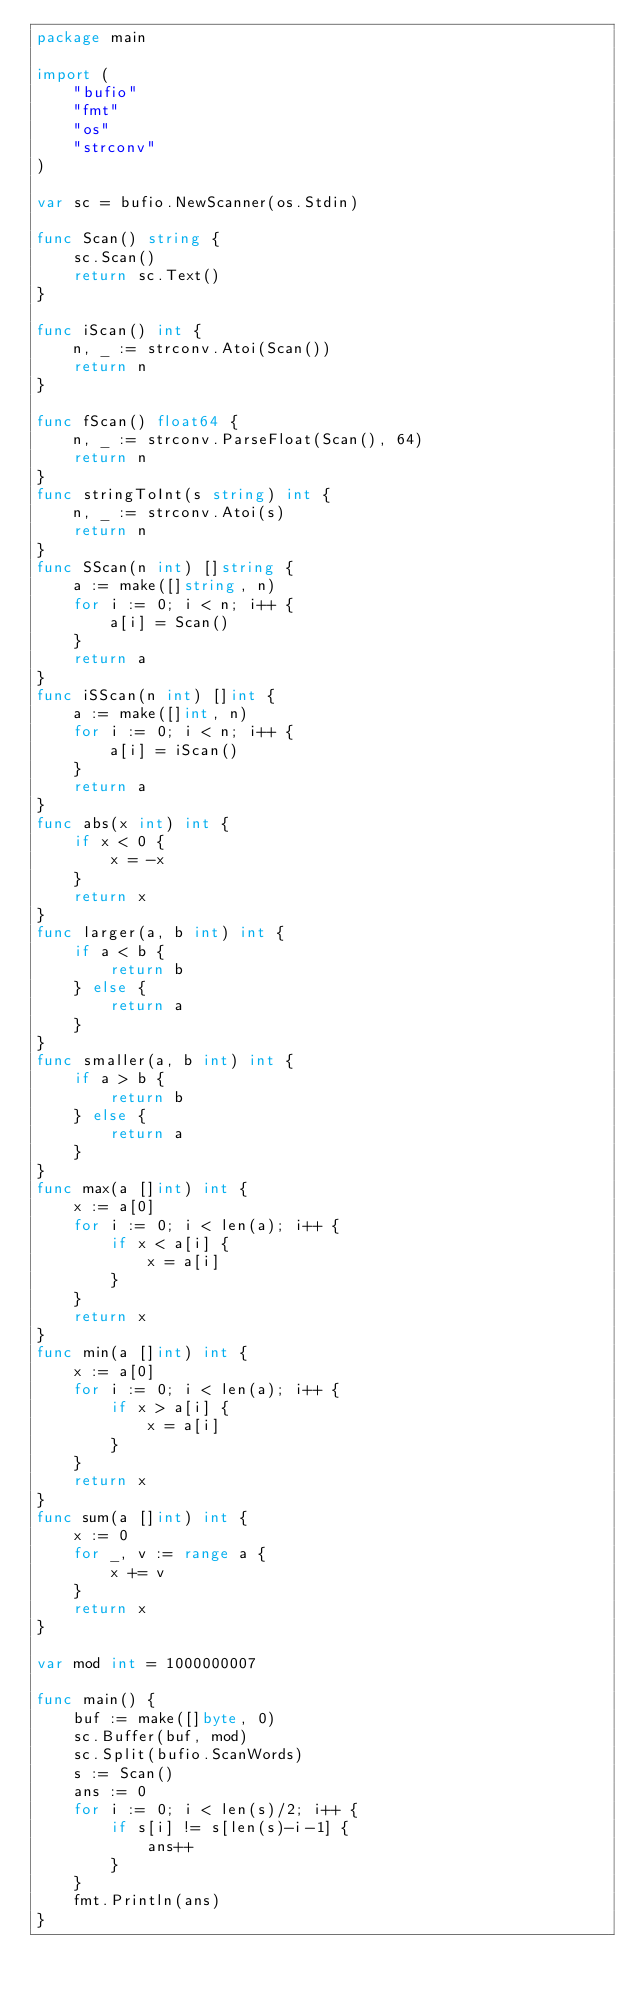Convert code to text. <code><loc_0><loc_0><loc_500><loc_500><_Go_>package main

import (
	"bufio"
	"fmt"
	"os"
	"strconv"
)

var sc = bufio.NewScanner(os.Stdin)

func Scan() string {
	sc.Scan()
	return sc.Text()
}

func iScan() int {
	n, _ := strconv.Atoi(Scan())
	return n
}

func fScan() float64 {
	n, _ := strconv.ParseFloat(Scan(), 64)
	return n
}
func stringToInt(s string) int {
	n, _ := strconv.Atoi(s)
	return n
}
func SScan(n int) []string {
	a := make([]string, n)
	for i := 0; i < n; i++ {
		a[i] = Scan()
	}
	return a
}
func iSScan(n int) []int {
	a := make([]int, n)
	for i := 0; i < n; i++ {
		a[i] = iScan()
	}
	return a
}
func abs(x int) int {
	if x < 0 {
		x = -x
	}
	return x
}
func larger(a, b int) int {
	if a < b {
		return b
	} else {
		return a
	}
}
func smaller(a, b int) int {
	if a > b {
		return b
	} else {
		return a
	}
}
func max(a []int) int {
	x := a[0]
	for i := 0; i < len(a); i++ {
		if x < a[i] {
			x = a[i]
		}
	}
	return x
}
func min(a []int) int {
	x := a[0]
	for i := 0; i < len(a); i++ {
		if x > a[i] {
			x = a[i]
		}
	}
	return x
}
func sum(a []int) int {
	x := 0
	for _, v := range a {
		x += v
	}
	return x
}

var mod int = 1000000007

func main() {
	buf := make([]byte, 0)
	sc.Buffer(buf, mod)
	sc.Split(bufio.ScanWords)
	s := Scan()
	ans := 0
	for i := 0; i < len(s)/2; i++ {
		if s[i] != s[len(s)-i-1] {
			ans++
		}
	}
	fmt.Println(ans)
}
</code> 